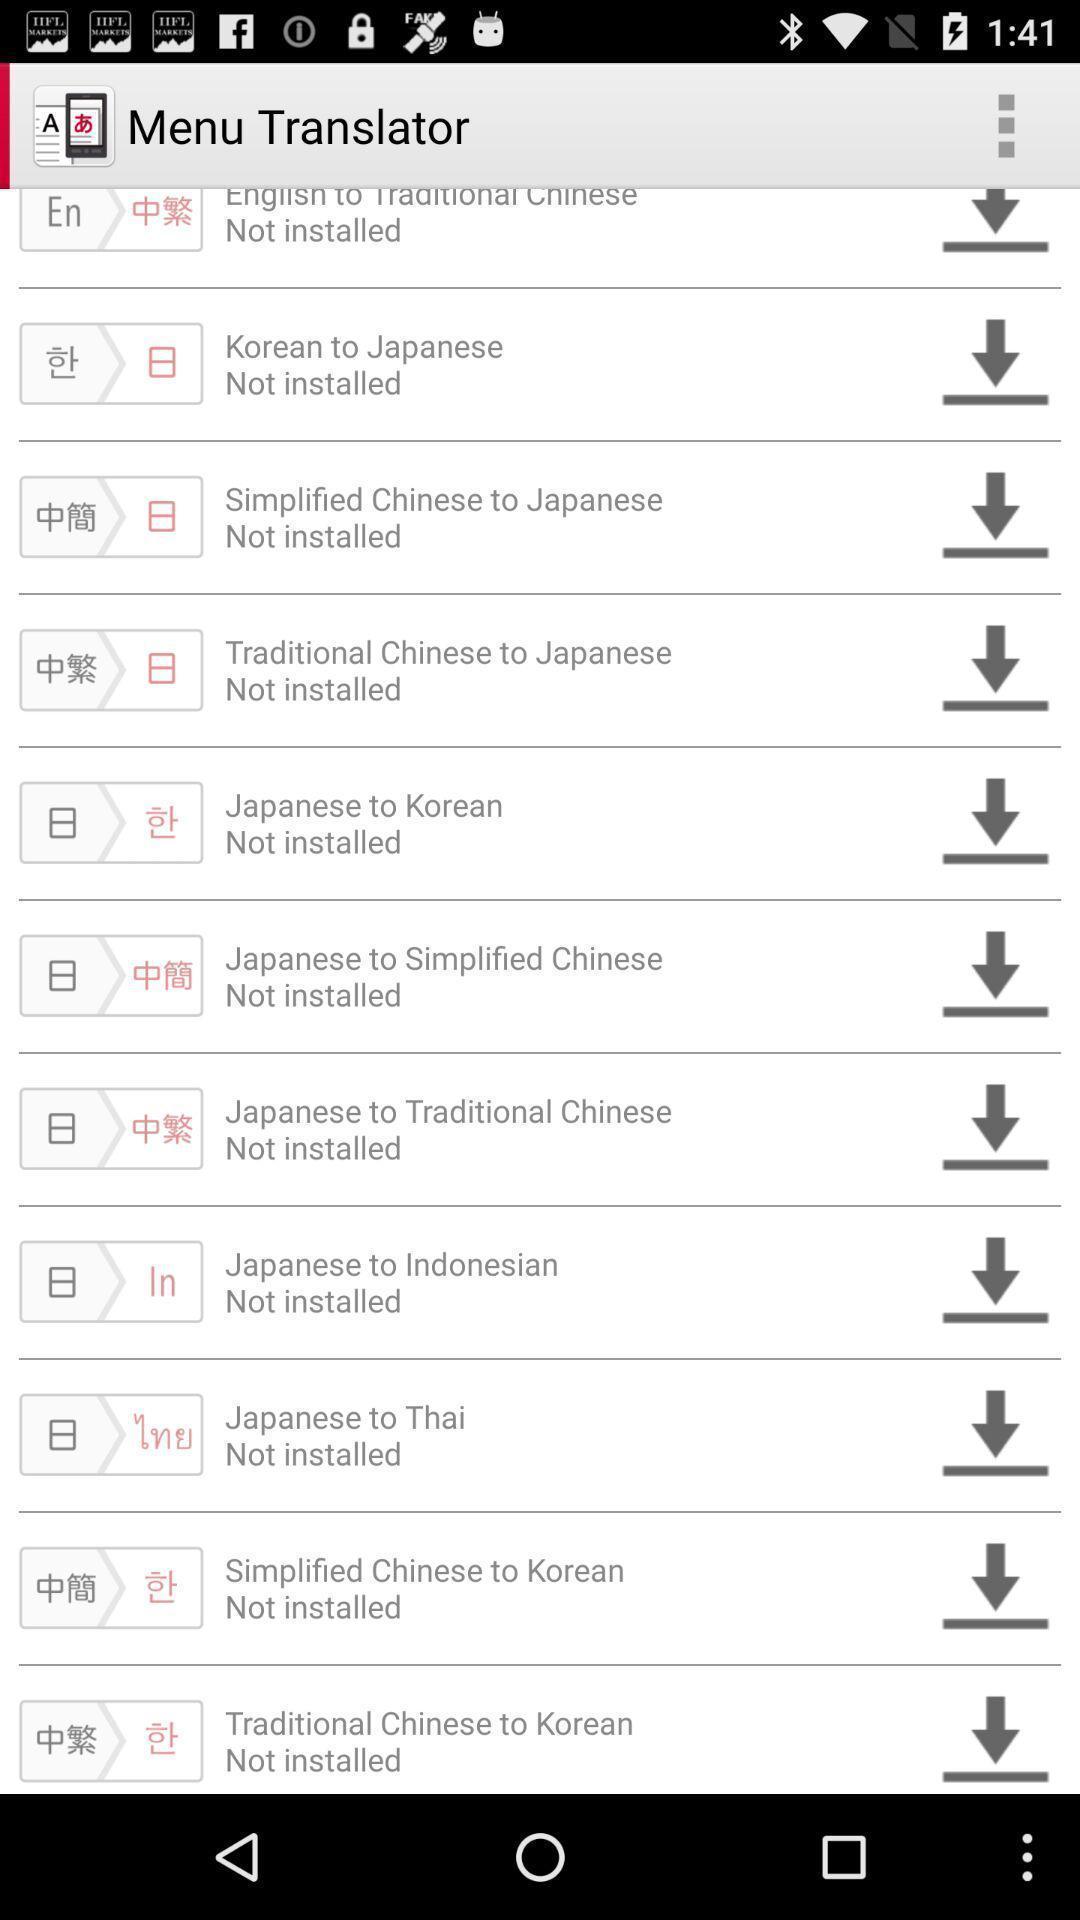Give me a summary of this screen capture. Page displaying various language translation files. 